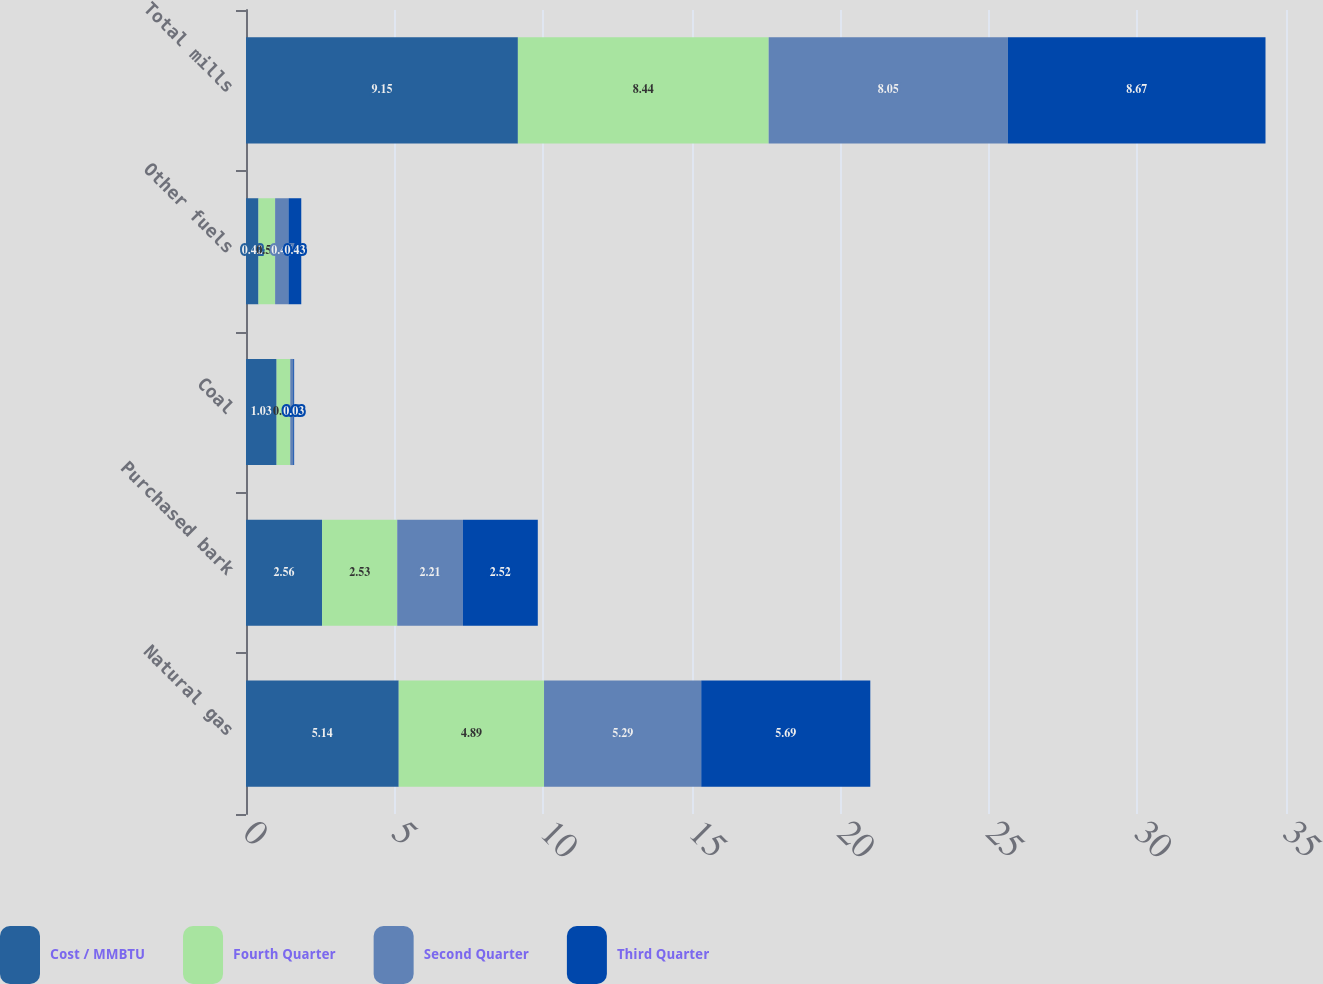Convert chart to OTSL. <chart><loc_0><loc_0><loc_500><loc_500><stacked_bar_chart><ecel><fcel>Natural gas<fcel>Purchased bark<fcel>Coal<fcel>Other fuels<fcel>Total mills<nl><fcel>Cost / MMBTU<fcel>5.14<fcel>2.56<fcel>1.03<fcel>0.42<fcel>9.15<nl><fcel>Fourth Quarter<fcel>4.89<fcel>2.53<fcel>0.46<fcel>0.56<fcel>8.44<nl><fcel>Second Quarter<fcel>5.29<fcel>2.21<fcel>0.1<fcel>0.45<fcel>8.05<nl><fcel>Third Quarter<fcel>5.69<fcel>2.52<fcel>0.03<fcel>0.43<fcel>8.67<nl></chart> 